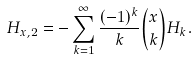<formula> <loc_0><loc_0><loc_500><loc_500>H _ { x , 2 } = - \sum _ { k = 1 } ^ { \infty } { \frac { ( - 1 ) ^ { k } } { k } } { \binom { x } { k } } H _ { k } .</formula> 